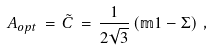<formula> <loc_0><loc_0><loc_500><loc_500>A _ { o p t } \, = \, \tilde { C } \, = \, \frac { 1 } { 2 \sqrt { 3 } } \left ( \mathbb { m } { 1 } - \Sigma \right ) \, ,</formula> 